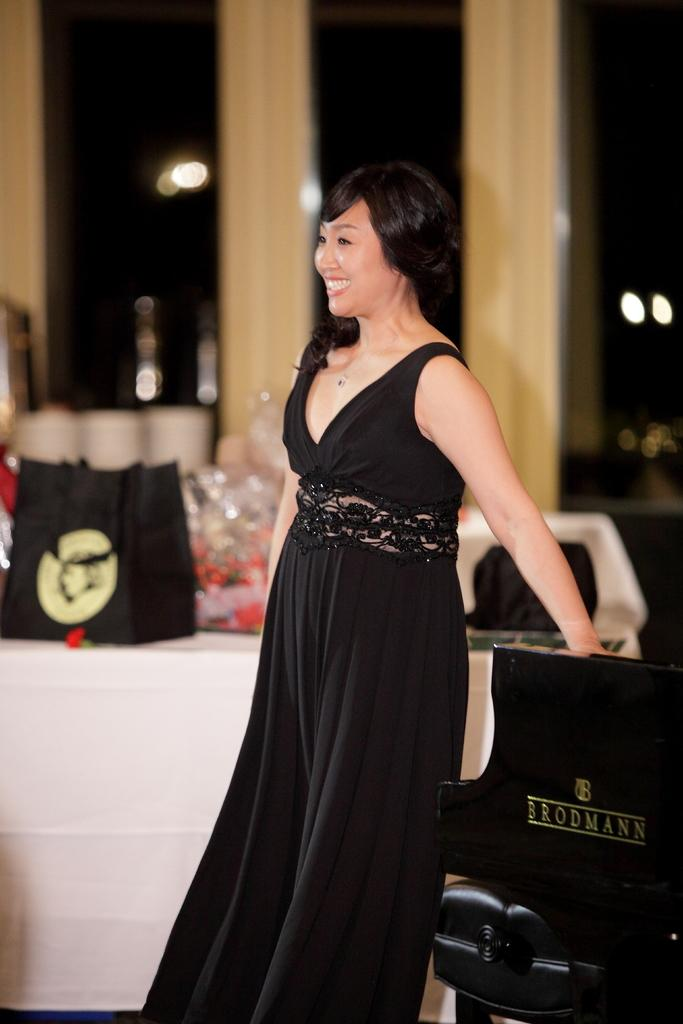Who is the main subject in the image? There is a woman in the image. What is the woman doing in the image? The woman is standing and smiling. What can be seen in the background of the image? There is a table in the background of the image, and there are objects on the table. How would you describe the quality of the background in the image? The background of the image is blurred. What type of medical advice is the woman giving in the image? There is no indication in the image that the woman is a doctor or providing medical advice. 